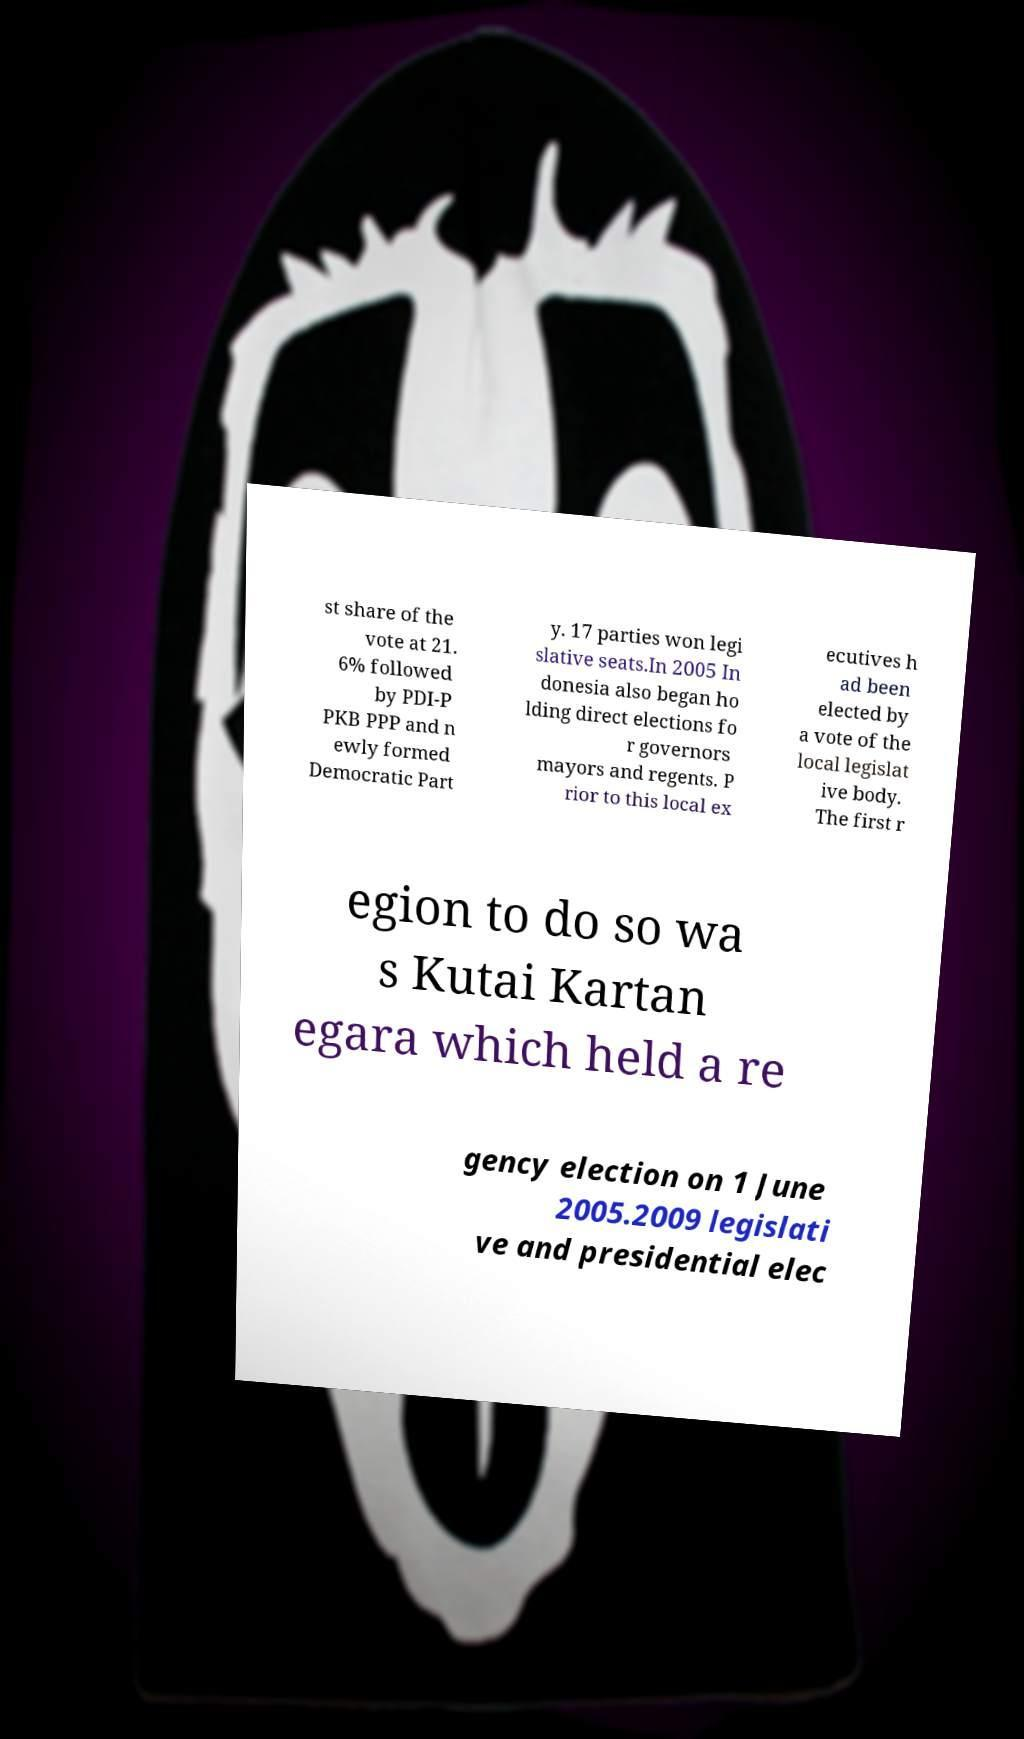Can you accurately transcribe the text from the provided image for me? st share of the vote at 21. 6% followed by PDI-P PKB PPP and n ewly formed Democratic Part y. 17 parties won legi slative seats.In 2005 In donesia also began ho lding direct elections fo r governors mayors and regents. P rior to this local ex ecutives h ad been elected by a vote of the local legislat ive body. The first r egion to do so wa s Kutai Kartan egara which held a re gency election on 1 June 2005.2009 legislati ve and presidential elec 